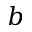Convert formula to latex. <formula><loc_0><loc_0><loc_500><loc_500>b</formula> 